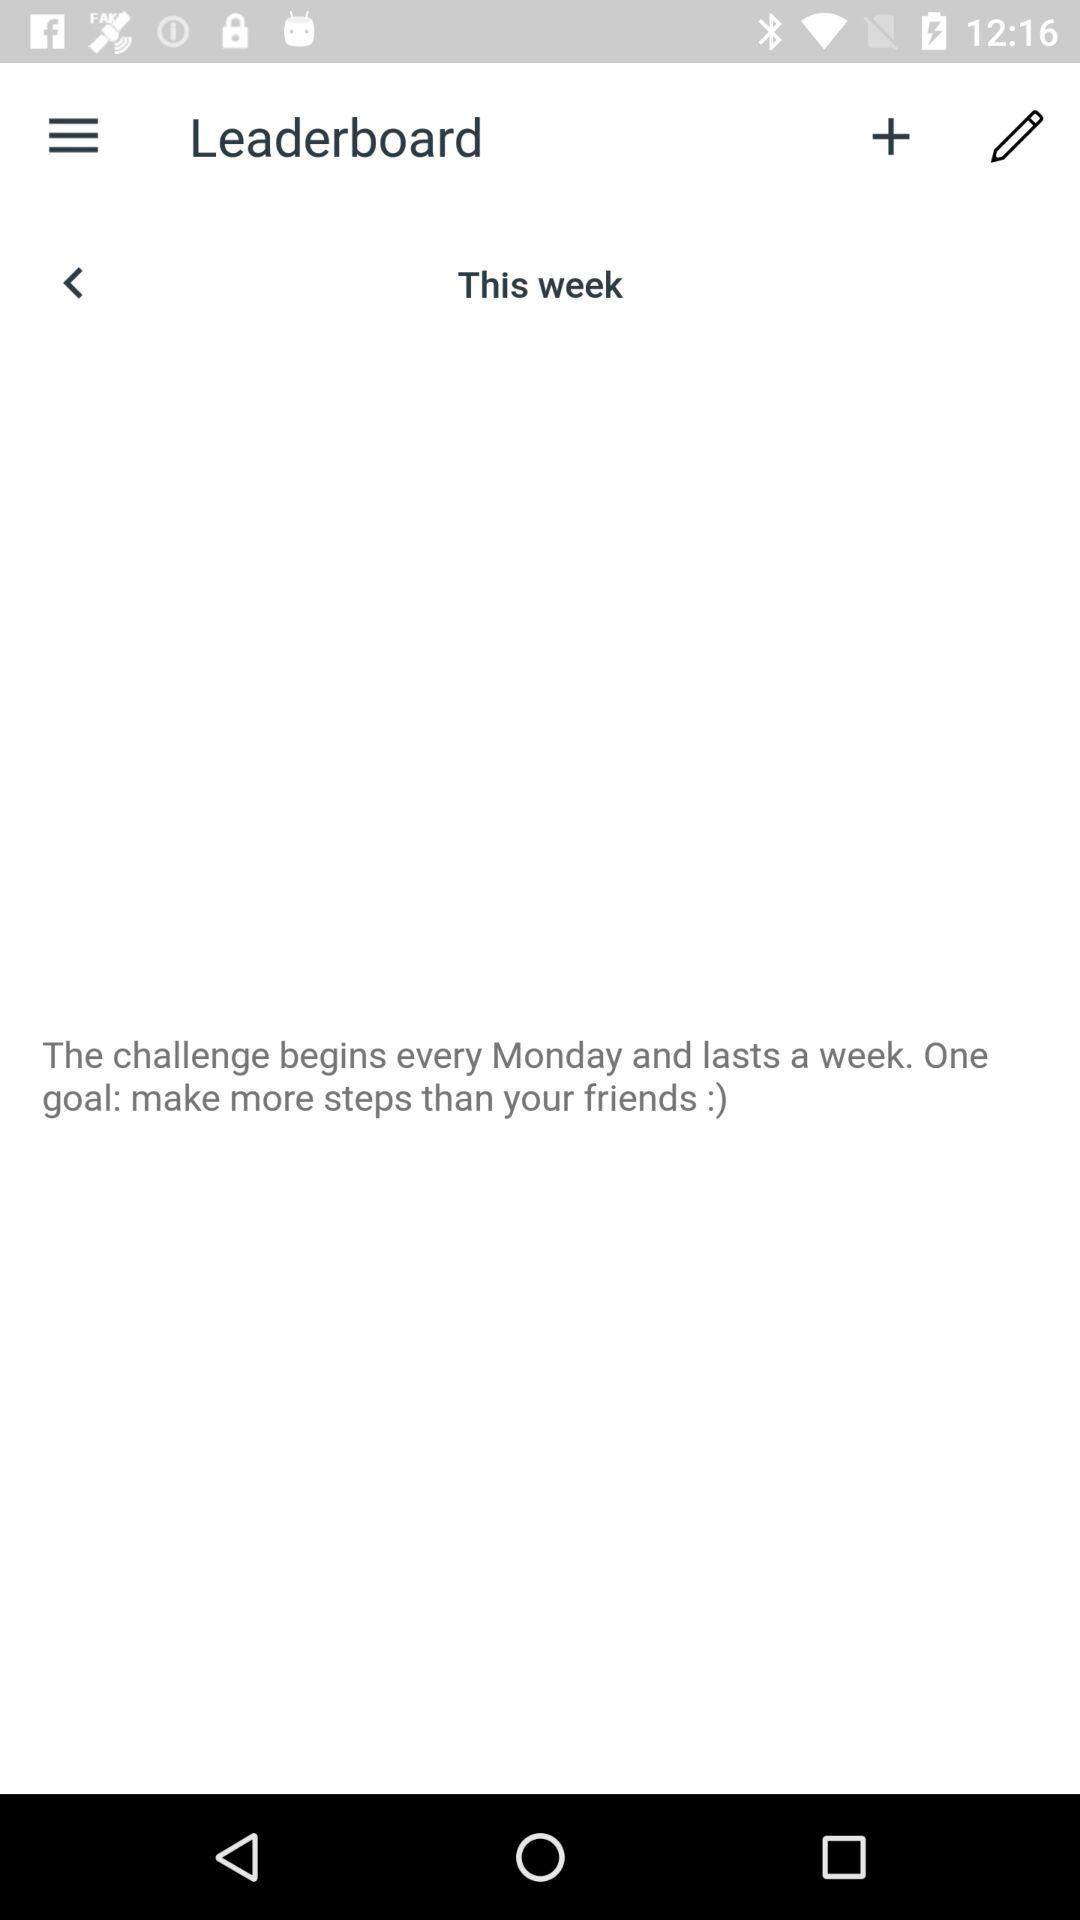What is the goal? The goal is to make more steps than your friends. 